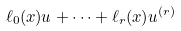Convert formula to latex. <formula><loc_0><loc_0><loc_500><loc_500>\ell _ { 0 } ( x ) u + \cdots + \ell _ { r } ( x ) u ^ { ( r ) }</formula> 